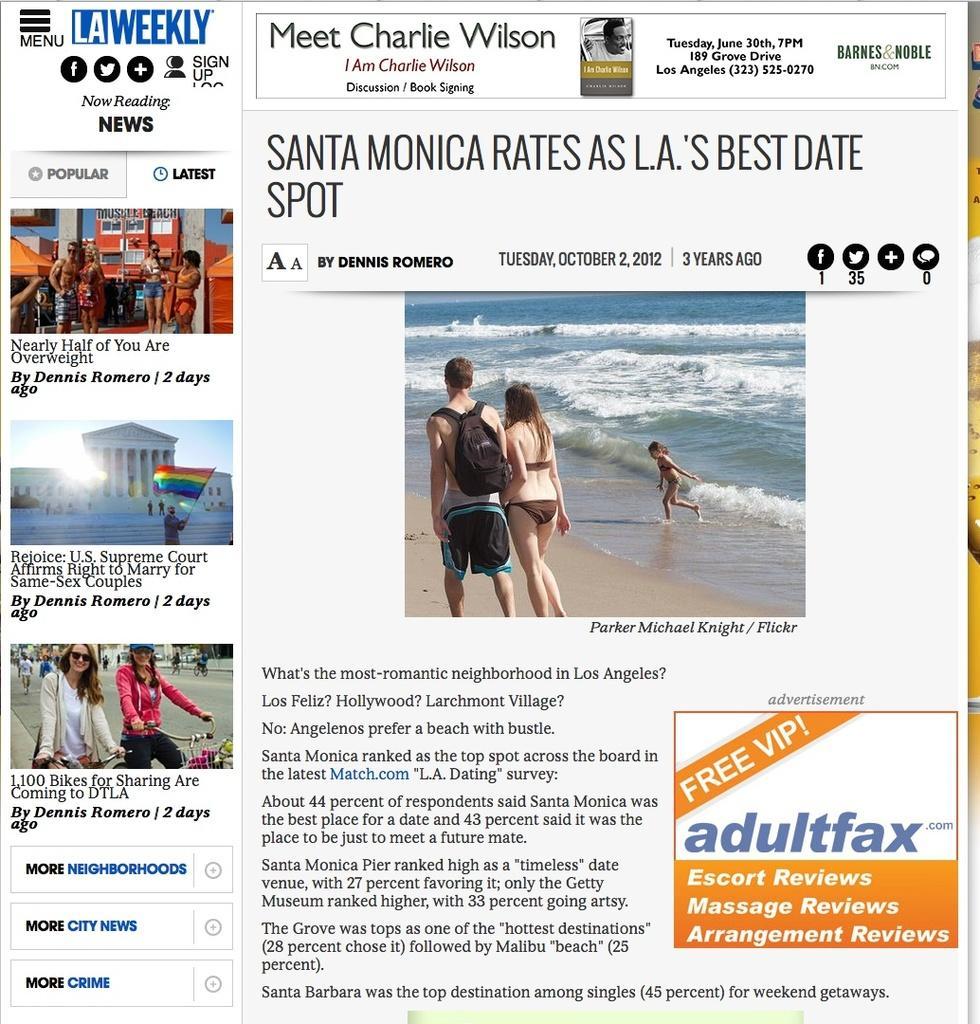In one or two sentences, can you explain what this image depicts? In this image there are texts written on it and there is the image in which there is water and there are persons walking and on the left side there are images of the person standing and there are buildings and there is a flag in the front and there are persons sitting on a bicycle. 